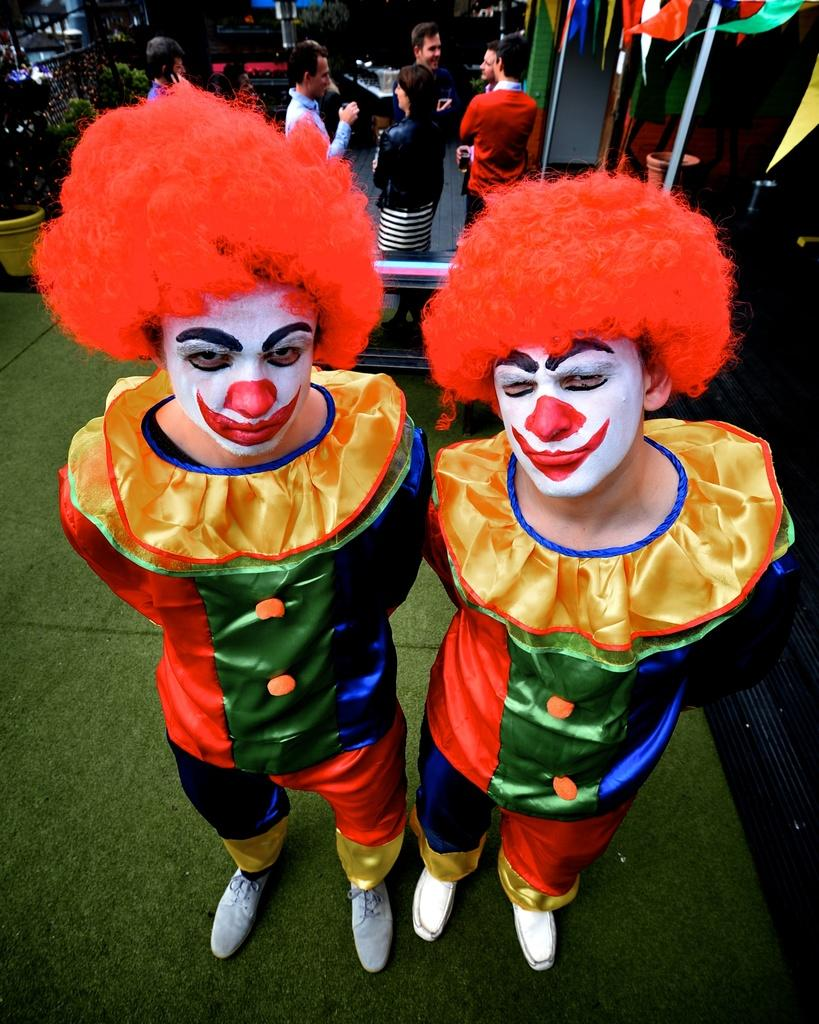How many people are in the image? There are two persons in the image. What are the people wearing? Both persons are wearing joker dresses and red color wigs. Can you describe the background of the image? There are other persons in the background of the image, as well as a bench. What is on the left side of the image? There is a flower pot on the left side of the image. What type of stove can be seen in the image? There is no stove present in the image. What is the queen's role in the image? There is no queen present in the image. 